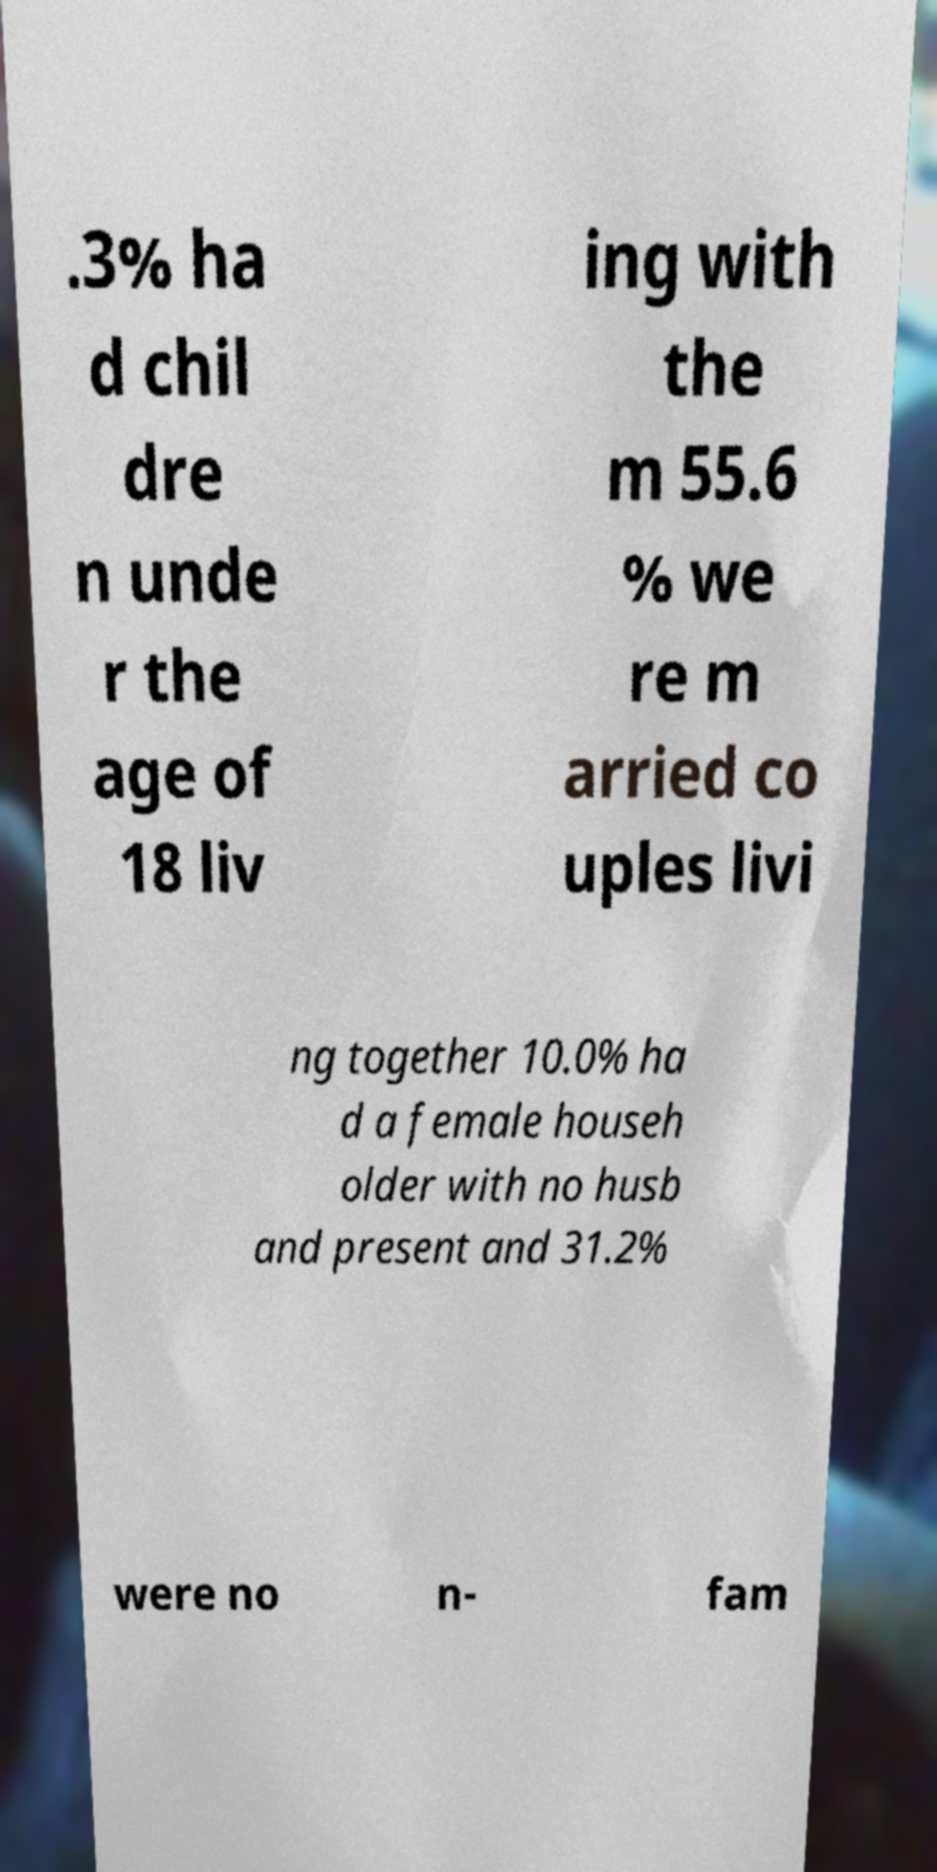For documentation purposes, I need the text within this image transcribed. Could you provide that? .3% ha d chil dre n unde r the age of 18 liv ing with the m 55.6 % we re m arried co uples livi ng together 10.0% ha d a female househ older with no husb and present and 31.2% were no n- fam 